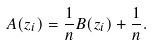<formula> <loc_0><loc_0><loc_500><loc_500>A ( z _ { i } ) = \frac { 1 } { n } B ( z _ { i } ) + \frac { 1 } { n } .</formula> 